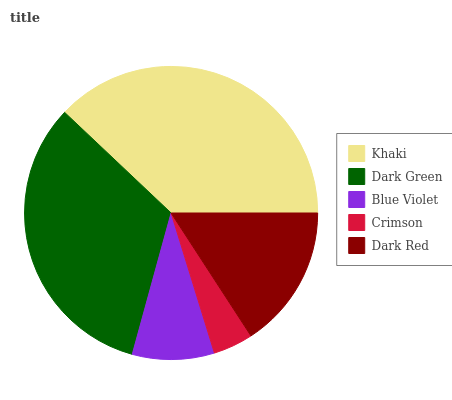Is Crimson the minimum?
Answer yes or no. Yes. Is Khaki the maximum?
Answer yes or no. Yes. Is Dark Green the minimum?
Answer yes or no. No. Is Dark Green the maximum?
Answer yes or no. No. Is Khaki greater than Dark Green?
Answer yes or no. Yes. Is Dark Green less than Khaki?
Answer yes or no. Yes. Is Dark Green greater than Khaki?
Answer yes or no. No. Is Khaki less than Dark Green?
Answer yes or no. No. Is Dark Red the high median?
Answer yes or no. Yes. Is Dark Red the low median?
Answer yes or no. Yes. Is Crimson the high median?
Answer yes or no. No. Is Dark Green the low median?
Answer yes or no. No. 